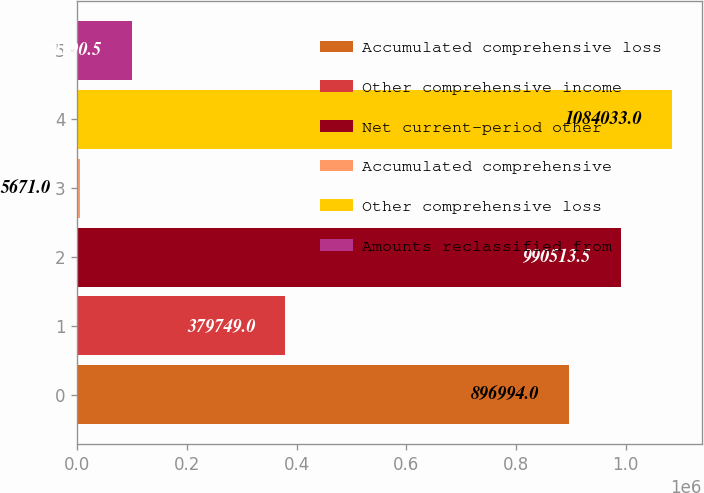Convert chart. <chart><loc_0><loc_0><loc_500><loc_500><bar_chart><fcel>Accumulated comprehensive loss<fcel>Other comprehensive income<fcel>Net current-period other<fcel>Accumulated comprehensive<fcel>Other comprehensive loss<fcel>Amounts reclassified from<nl><fcel>896994<fcel>379749<fcel>990514<fcel>5671<fcel>1.08403e+06<fcel>99190.5<nl></chart> 